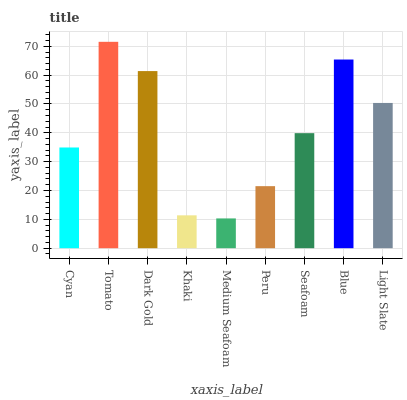Is Dark Gold the minimum?
Answer yes or no. No. Is Dark Gold the maximum?
Answer yes or no. No. Is Tomato greater than Dark Gold?
Answer yes or no. Yes. Is Dark Gold less than Tomato?
Answer yes or no. Yes. Is Dark Gold greater than Tomato?
Answer yes or no. No. Is Tomato less than Dark Gold?
Answer yes or no. No. Is Seafoam the high median?
Answer yes or no. Yes. Is Seafoam the low median?
Answer yes or no. Yes. Is Peru the high median?
Answer yes or no. No. Is Medium Seafoam the low median?
Answer yes or no. No. 